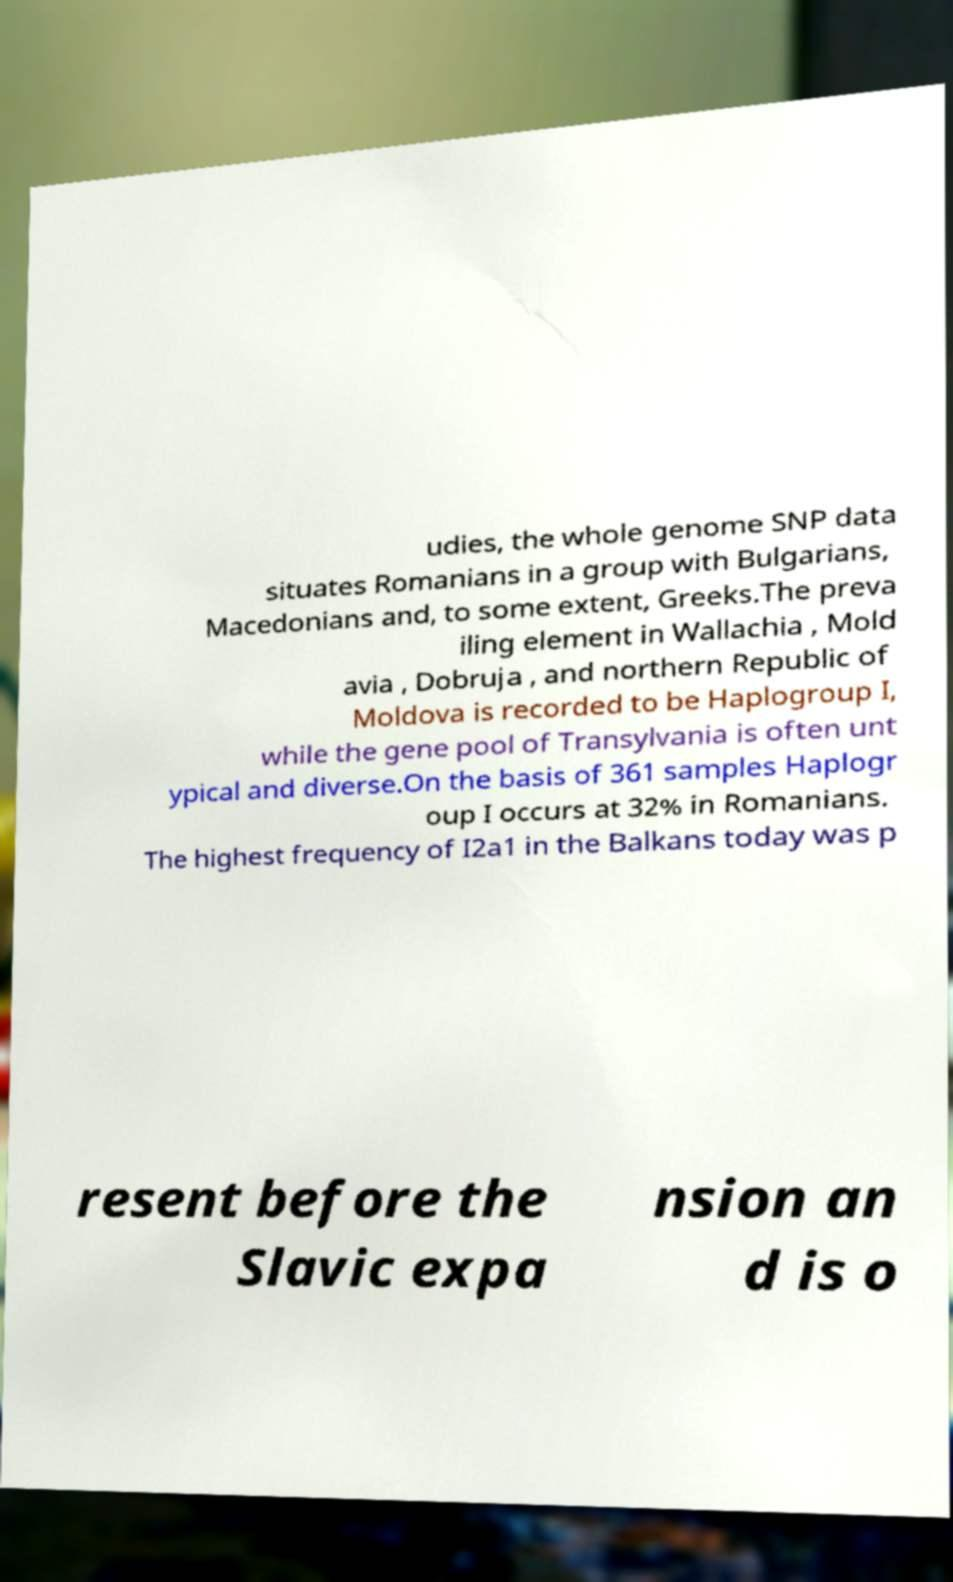There's text embedded in this image that I need extracted. Can you transcribe it verbatim? udies, the whole genome SNP data situates Romanians in a group with Bulgarians, Macedonians and, to some extent, Greeks.The preva iling element in Wallachia , Mold avia , Dobruja , and northern Republic of Moldova is recorded to be Haplogroup I, while the gene pool of Transylvania is often unt ypical and diverse.On the basis of 361 samples Haplogr oup I occurs at 32% in Romanians. The highest frequency of I2a1 in the Balkans today was p resent before the Slavic expa nsion an d is o 